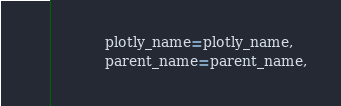<code> <loc_0><loc_0><loc_500><loc_500><_Python_>            plotly_name=plotly_name,
            parent_name=parent_name,</code> 